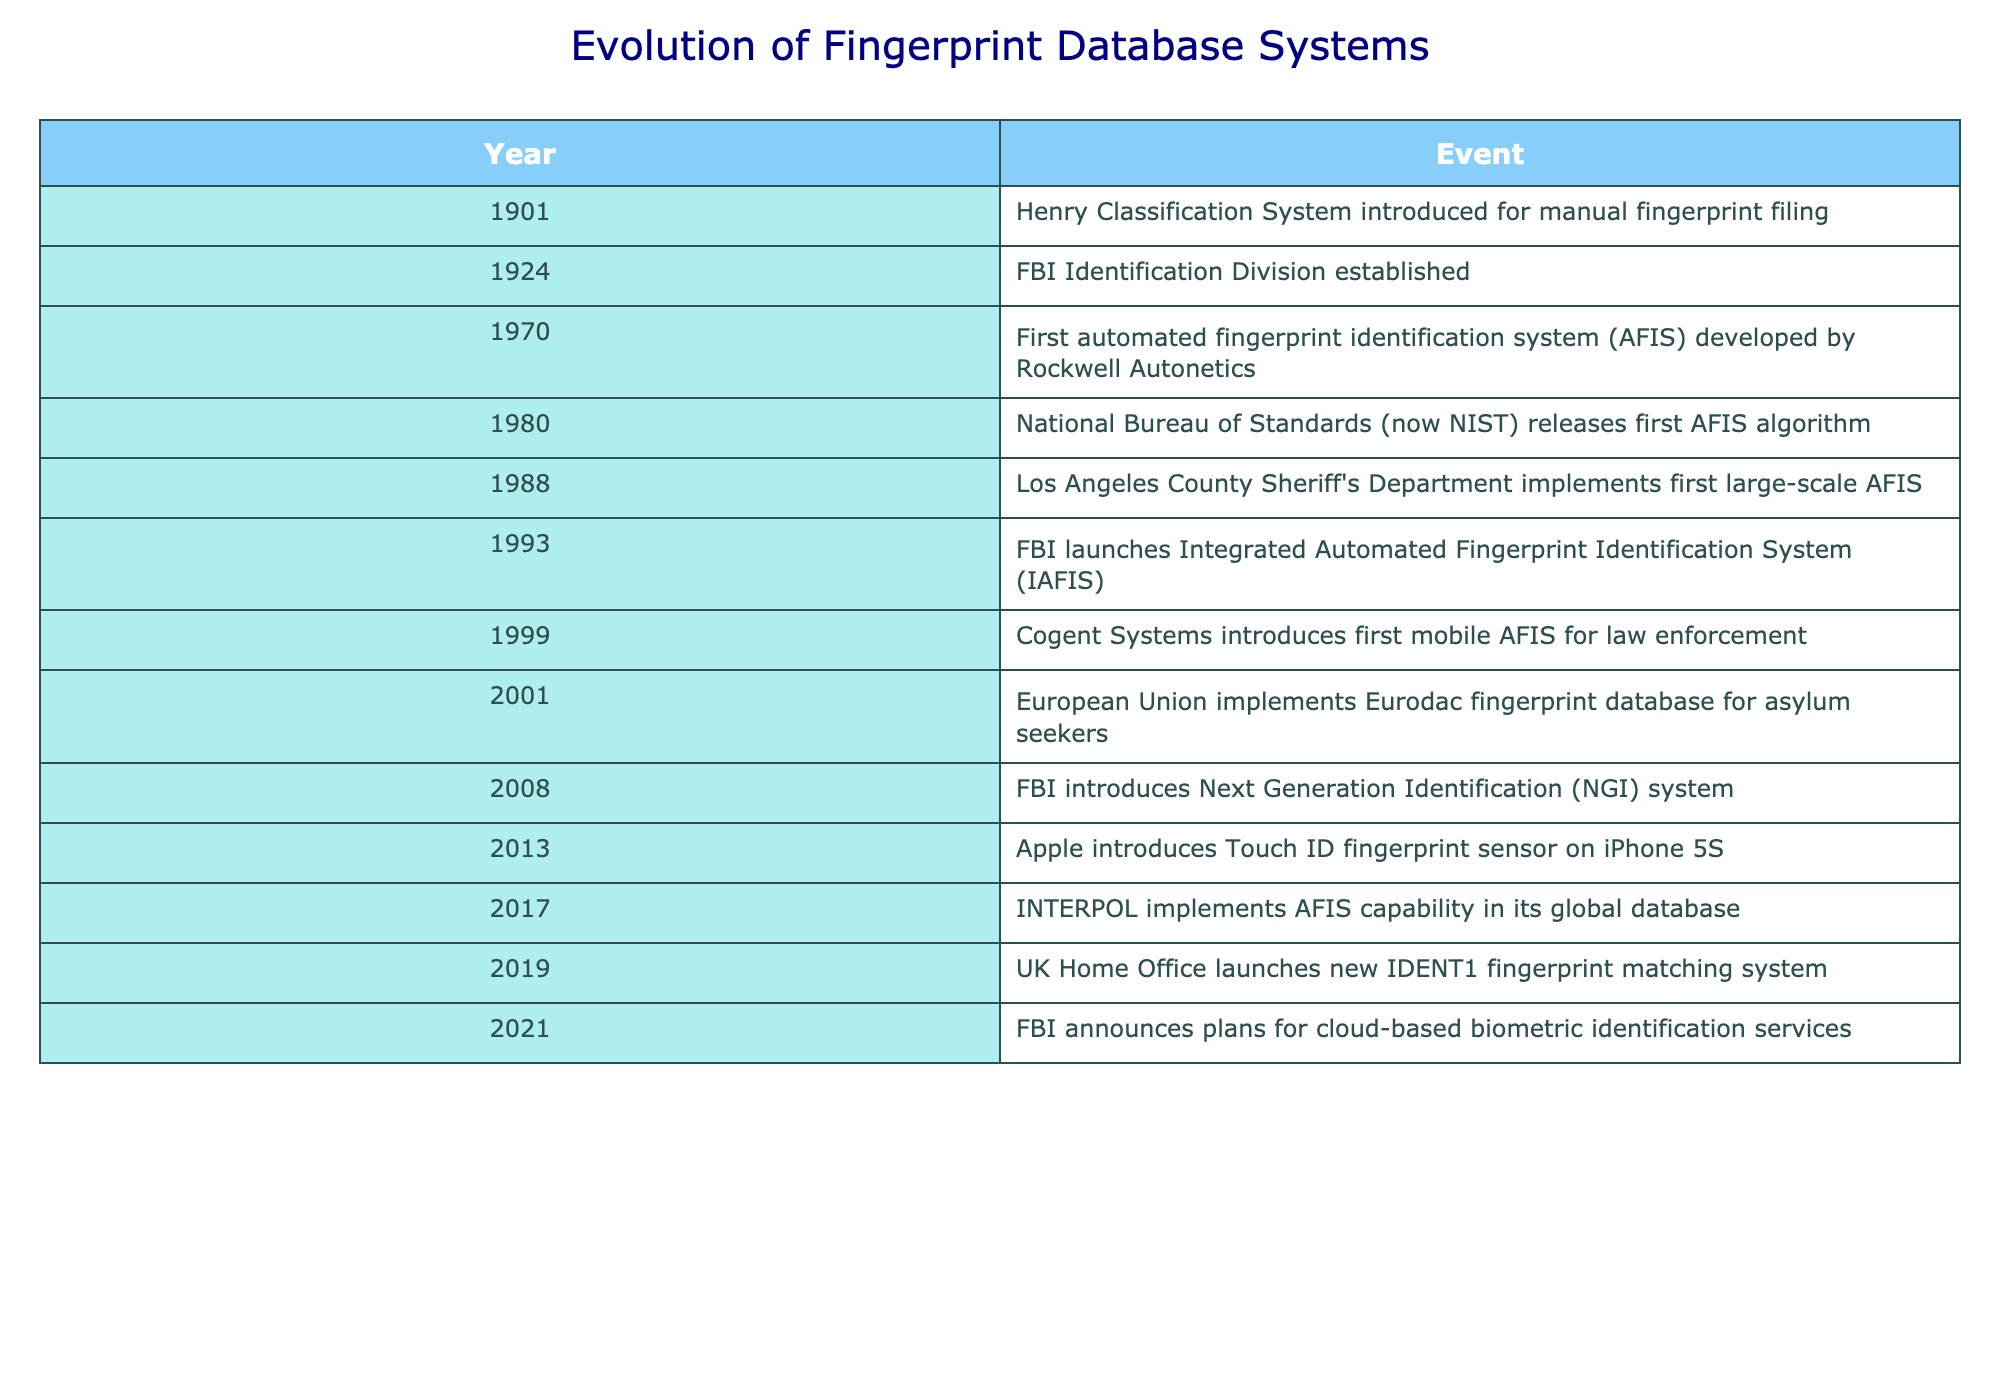What year was the first automated fingerprint identification system developed? The table indicates that the first automated fingerprint identification system (AFIS) was developed in 1970. Thus, the answer is directly found in the relevant row of the table.
Answer: 1970 Which event occurred in the same decade as the introduction of the Touch ID fingerprint sensor? The Touch ID fingerprint sensor was introduced in 2013, which falls in the 2010s decade. Looking at the table, there is no other event listed from the 2010s decade. Therefore, there are no additional events to compare within that decade in this data.
Answer: None How many years are there between the introduction of the Henry Classification System and the launch of IAFIS? The Henry Classification System was introduced in 1901, and IAFIS was launched in 1993. To find the difference, we subtract 1901 from 1993, which yields 1993 - 1901 = 92.
Answer: 92 years Did the development of mobile AFIS occur before or after the establishment of the FBI Identification Division? The FBI Identification Division was established in 1924, and mobile AFIS was introduced in 1999. Since 1999 is later than 1924, mobile AFIS came after the establishment of the FBI Identification Division.
Answer: After What was the first organization to implement a large-scale AFIS? According to the table, the Los Angeles County Sheriff's Department implemented the first large-scale AFIS in 1988. This fact can be found directly in the event column corresponding to the year 1988.
Answer: Los Angeles County Sheriff's Department In which year did both the FBI launch IAFIS and Apple introduce Touch ID, and how many years apart were they? IAFIS was launched in 1993 and Touch ID was introduced in 2013. To find the years apart, we subtract the two years, resulting in 2013 - 1993 = 20 years. Thus, they didn't occur in the same year and are separated by 20 years.
Answer: 20 years apart What percentage of the listed events occurred before 2000? There are a total of 12 events listed, with 7 of those occurring before 2000 (from 1901 to 1999). To calculate the percentage, we take 7 events / 12 total events * 100 = 58.33%. Thus, we can round this to approximately 58%.
Answer: Approximately 58% Which event represents the most recent significant development in fingerprint identification as per the table? The table shows the latest event listed is from 2021 when the FBI announced plans for cloud-based biometric identification services. This enables us to conclude that it is the most recent significant development in fingerprint identification contained within the table.
Answer: 2021 What is the total number of years from the establishment of the FBI Identification Division to the implementation of the Eurodac fingerprint database? The FBI Identification Division was established in 1924, and the Eurodac fingerprint database was implemented in 2001. To find the total number of years, we calculate 2001 - 1924 = 77 years.
Answer: 77 years 